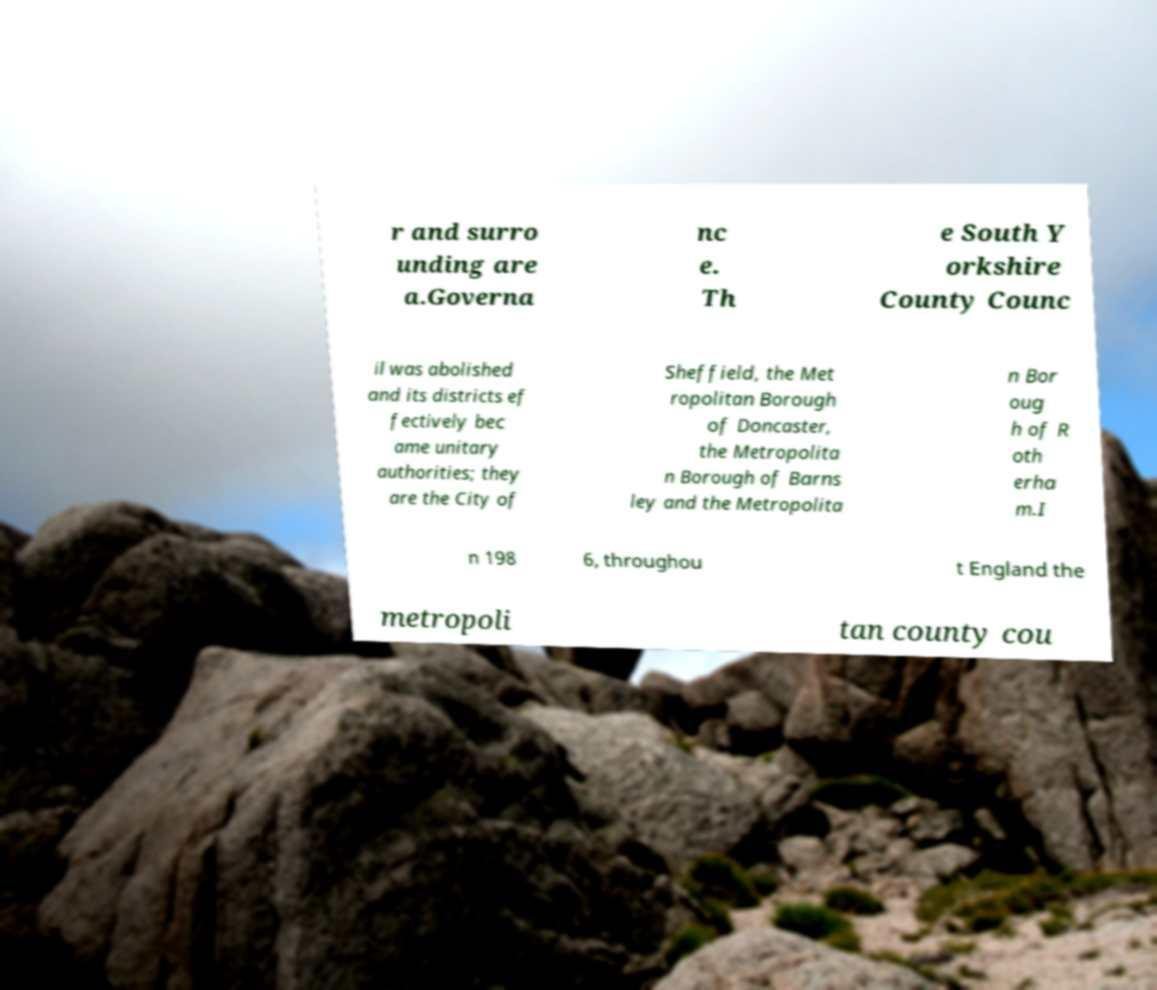Can you read and provide the text displayed in the image?This photo seems to have some interesting text. Can you extract and type it out for me? r and surro unding are a.Governa nc e. Th e South Y orkshire County Counc il was abolished and its districts ef fectively bec ame unitary authorities; they are the City of Sheffield, the Met ropolitan Borough of Doncaster, the Metropolita n Borough of Barns ley and the Metropolita n Bor oug h of R oth erha m.I n 198 6, throughou t England the metropoli tan county cou 